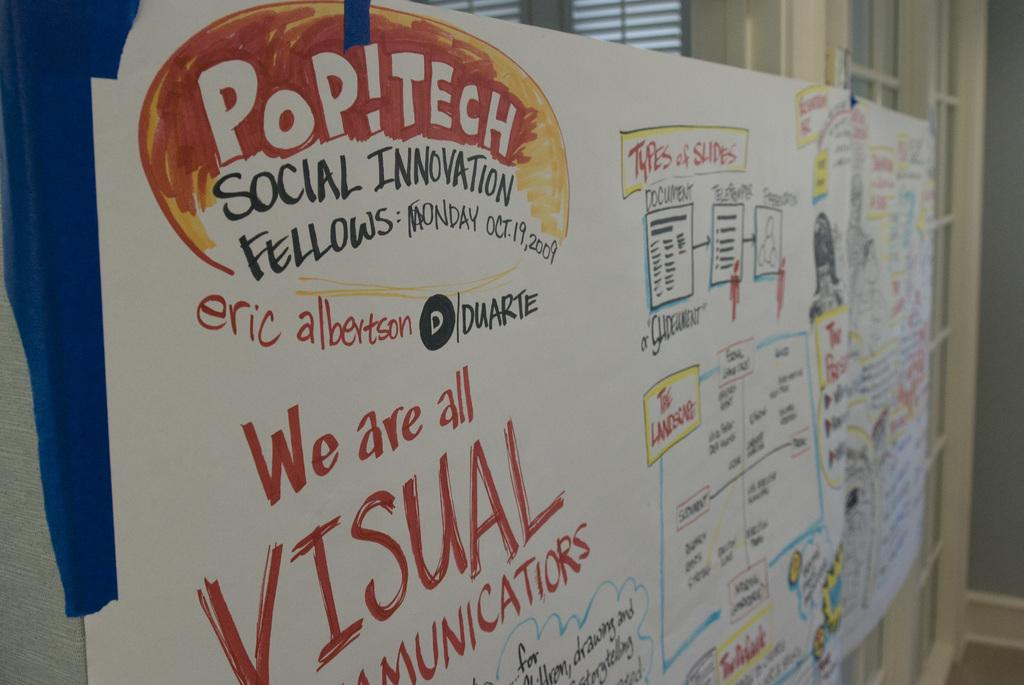<image>
Offer a succinct explanation of the picture presented. A poster with orange writing refers to Pop!Tech. 